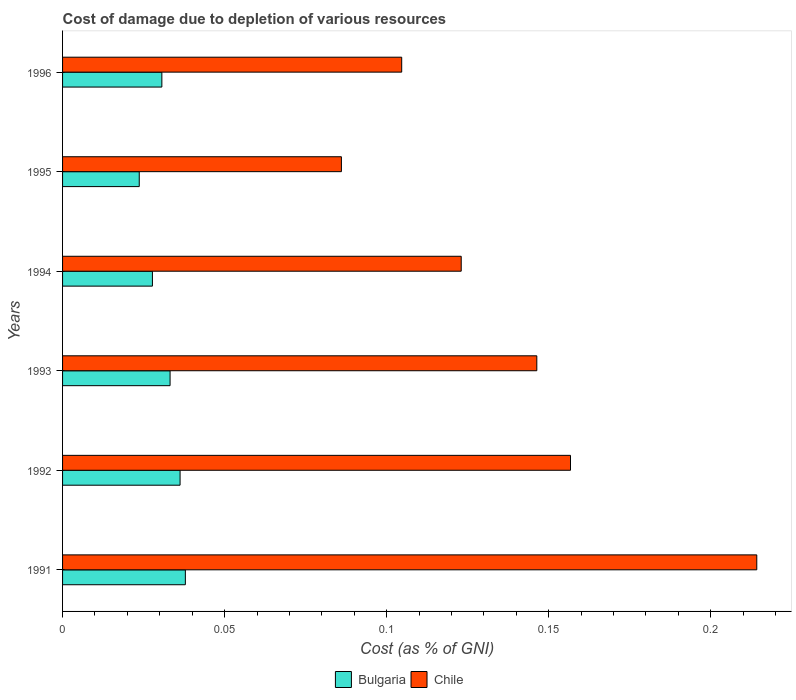Are the number of bars on each tick of the Y-axis equal?
Provide a succinct answer. Yes. How many bars are there on the 6th tick from the bottom?
Ensure brevity in your answer.  2. What is the label of the 4th group of bars from the top?
Provide a short and direct response. 1993. In how many cases, is the number of bars for a given year not equal to the number of legend labels?
Your answer should be very brief. 0. What is the cost of damage caused due to the depletion of various resources in Chile in 1996?
Provide a short and direct response. 0.1. Across all years, what is the maximum cost of damage caused due to the depletion of various resources in Chile?
Give a very brief answer. 0.21. Across all years, what is the minimum cost of damage caused due to the depletion of various resources in Chile?
Offer a terse response. 0.09. In which year was the cost of damage caused due to the depletion of various resources in Bulgaria maximum?
Offer a very short reply. 1991. In which year was the cost of damage caused due to the depletion of various resources in Chile minimum?
Your answer should be compact. 1995. What is the total cost of damage caused due to the depletion of various resources in Chile in the graph?
Your response must be concise. 0.83. What is the difference between the cost of damage caused due to the depletion of various resources in Bulgaria in 1991 and that in 1995?
Provide a short and direct response. 0.01. What is the difference between the cost of damage caused due to the depletion of various resources in Chile in 1994 and the cost of damage caused due to the depletion of various resources in Bulgaria in 1993?
Your response must be concise. 0.09. What is the average cost of damage caused due to the depletion of various resources in Bulgaria per year?
Offer a terse response. 0.03. In the year 1992, what is the difference between the cost of damage caused due to the depletion of various resources in Bulgaria and cost of damage caused due to the depletion of various resources in Chile?
Ensure brevity in your answer.  -0.12. In how many years, is the cost of damage caused due to the depletion of various resources in Chile greater than 0.01 %?
Make the answer very short. 6. What is the ratio of the cost of damage caused due to the depletion of various resources in Bulgaria in 1992 to that in 1993?
Make the answer very short. 1.09. Is the cost of damage caused due to the depletion of various resources in Chile in 1994 less than that in 1996?
Provide a succinct answer. No. Is the difference between the cost of damage caused due to the depletion of various resources in Bulgaria in 1991 and 1994 greater than the difference between the cost of damage caused due to the depletion of various resources in Chile in 1991 and 1994?
Keep it short and to the point. No. What is the difference between the highest and the second highest cost of damage caused due to the depletion of various resources in Bulgaria?
Give a very brief answer. 0. What is the difference between the highest and the lowest cost of damage caused due to the depletion of various resources in Chile?
Your answer should be compact. 0.13. Is the sum of the cost of damage caused due to the depletion of various resources in Chile in 1991 and 1995 greater than the maximum cost of damage caused due to the depletion of various resources in Bulgaria across all years?
Your answer should be very brief. Yes. What does the 2nd bar from the top in 1993 represents?
Ensure brevity in your answer.  Bulgaria. What does the 2nd bar from the bottom in 1993 represents?
Your response must be concise. Chile. How many years are there in the graph?
Offer a terse response. 6. What is the difference between two consecutive major ticks on the X-axis?
Provide a succinct answer. 0.05. Does the graph contain any zero values?
Make the answer very short. No. Does the graph contain grids?
Your answer should be very brief. No. Where does the legend appear in the graph?
Ensure brevity in your answer.  Bottom center. How are the legend labels stacked?
Keep it short and to the point. Horizontal. What is the title of the graph?
Keep it short and to the point. Cost of damage due to depletion of various resources. Does "Latvia" appear as one of the legend labels in the graph?
Make the answer very short. No. What is the label or title of the X-axis?
Give a very brief answer. Cost (as % of GNI). What is the Cost (as % of GNI) in Bulgaria in 1991?
Offer a terse response. 0.04. What is the Cost (as % of GNI) of Chile in 1991?
Your answer should be very brief. 0.21. What is the Cost (as % of GNI) in Bulgaria in 1992?
Provide a succinct answer. 0.04. What is the Cost (as % of GNI) of Chile in 1992?
Your answer should be very brief. 0.16. What is the Cost (as % of GNI) in Bulgaria in 1993?
Keep it short and to the point. 0.03. What is the Cost (as % of GNI) of Chile in 1993?
Make the answer very short. 0.15. What is the Cost (as % of GNI) of Bulgaria in 1994?
Offer a very short reply. 0.03. What is the Cost (as % of GNI) in Chile in 1994?
Your response must be concise. 0.12. What is the Cost (as % of GNI) of Bulgaria in 1995?
Keep it short and to the point. 0.02. What is the Cost (as % of GNI) of Chile in 1995?
Make the answer very short. 0.09. What is the Cost (as % of GNI) of Bulgaria in 1996?
Provide a short and direct response. 0.03. What is the Cost (as % of GNI) in Chile in 1996?
Your answer should be very brief. 0.1. Across all years, what is the maximum Cost (as % of GNI) in Bulgaria?
Make the answer very short. 0.04. Across all years, what is the maximum Cost (as % of GNI) in Chile?
Make the answer very short. 0.21. Across all years, what is the minimum Cost (as % of GNI) in Bulgaria?
Provide a short and direct response. 0.02. Across all years, what is the minimum Cost (as % of GNI) of Chile?
Your answer should be compact. 0.09. What is the total Cost (as % of GNI) of Bulgaria in the graph?
Provide a succinct answer. 0.19. What is the total Cost (as % of GNI) in Chile in the graph?
Offer a very short reply. 0.83. What is the difference between the Cost (as % of GNI) in Bulgaria in 1991 and that in 1992?
Give a very brief answer. 0. What is the difference between the Cost (as % of GNI) of Chile in 1991 and that in 1992?
Provide a short and direct response. 0.06. What is the difference between the Cost (as % of GNI) of Bulgaria in 1991 and that in 1993?
Provide a short and direct response. 0. What is the difference between the Cost (as % of GNI) of Chile in 1991 and that in 1993?
Ensure brevity in your answer.  0.07. What is the difference between the Cost (as % of GNI) in Bulgaria in 1991 and that in 1994?
Offer a very short reply. 0.01. What is the difference between the Cost (as % of GNI) in Chile in 1991 and that in 1994?
Ensure brevity in your answer.  0.09. What is the difference between the Cost (as % of GNI) of Bulgaria in 1991 and that in 1995?
Offer a terse response. 0.01. What is the difference between the Cost (as % of GNI) of Chile in 1991 and that in 1995?
Ensure brevity in your answer.  0.13. What is the difference between the Cost (as % of GNI) in Bulgaria in 1991 and that in 1996?
Your answer should be compact. 0.01. What is the difference between the Cost (as % of GNI) in Chile in 1991 and that in 1996?
Your response must be concise. 0.11. What is the difference between the Cost (as % of GNI) of Bulgaria in 1992 and that in 1993?
Make the answer very short. 0. What is the difference between the Cost (as % of GNI) in Chile in 1992 and that in 1993?
Give a very brief answer. 0.01. What is the difference between the Cost (as % of GNI) in Bulgaria in 1992 and that in 1994?
Give a very brief answer. 0.01. What is the difference between the Cost (as % of GNI) in Chile in 1992 and that in 1994?
Offer a very short reply. 0.03. What is the difference between the Cost (as % of GNI) in Bulgaria in 1992 and that in 1995?
Provide a short and direct response. 0.01. What is the difference between the Cost (as % of GNI) of Chile in 1992 and that in 1995?
Ensure brevity in your answer.  0.07. What is the difference between the Cost (as % of GNI) of Bulgaria in 1992 and that in 1996?
Offer a terse response. 0.01. What is the difference between the Cost (as % of GNI) of Chile in 1992 and that in 1996?
Provide a succinct answer. 0.05. What is the difference between the Cost (as % of GNI) of Bulgaria in 1993 and that in 1994?
Keep it short and to the point. 0.01. What is the difference between the Cost (as % of GNI) in Chile in 1993 and that in 1994?
Ensure brevity in your answer.  0.02. What is the difference between the Cost (as % of GNI) in Bulgaria in 1993 and that in 1995?
Your answer should be very brief. 0.01. What is the difference between the Cost (as % of GNI) of Chile in 1993 and that in 1995?
Keep it short and to the point. 0.06. What is the difference between the Cost (as % of GNI) of Bulgaria in 1993 and that in 1996?
Your answer should be very brief. 0. What is the difference between the Cost (as % of GNI) of Chile in 1993 and that in 1996?
Give a very brief answer. 0.04. What is the difference between the Cost (as % of GNI) in Bulgaria in 1994 and that in 1995?
Keep it short and to the point. 0. What is the difference between the Cost (as % of GNI) in Chile in 1994 and that in 1995?
Provide a short and direct response. 0.04. What is the difference between the Cost (as % of GNI) of Bulgaria in 1994 and that in 1996?
Give a very brief answer. -0. What is the difference between the Cost (as % of GNI) in Chile in 1994 and that in 1996?
Give a very brief answer. 0.02. What is the difference between the Cost (as % of GNI) of Bulgaria in 1995 and that in 1996?
Ensure brevity in your answer.  -0.01. What is the difference between the Cost (as % of GNI) in Chile in 1995 and that in 1996?
Make the answer very short. -0.02. What is the difference between the Cost (as % of GNI) of Bulgaria in 1991 and the Cost (as % of GNI) of Chile in 1992?
Your answer should be very brief. -0.12. What is the difference between the Cost (as % of GNI) in Bulgaria in 1991 and the Cost (as % of GNI) in Chile in 1993?
Your response must be concise. -0.11. What is the difference between the Cost (as % of GNI) in Bulgaria in 1991 and the Cost (as % of GNI) in Chile in 1994?
Your answer should be very brief. -0.09. What is the difference between the Cost (as % of GNI) of Bulgaria in 1991 and the Cost (as % of GNI) of Chile in 1995?
Your answer should be very brief. -0.05. What is the difference between the Cost (as % of GNI) of Bulgaria in 1991 and the Cost (as % of GNI) of Chile in 1996?
Provide a succinct answer. -0.07. What is the difference between the Cost (as % of GNI) in Bulgaria in 1992 and the Cost (as % of GNI) in Chile in 1993?
Keep it short and to the point. -0.11. What is the difference between the Cost (as % of GNI) in Bulgaria in 1992 and the Cost (as % of GNI) in Chile in 1994?
Give a very brief answer. -0.09. What is the difference between the Cost (as % of GNI) of Bulgaria in 1992 and the Cost (as % of GNI) of Chile in 1995?
Offer a terse response. -0.05. What is the difference between the Cost (as % of GNI) in Bulgaria in 1992 and the Cost (as % of GNI) in Chile in 1996?
Make the answer very short. -0.07. What is the difference between the Cost (as % of GNI) in Bulgaria in 1993 and the Cost (as % of GNI) in Chile in 1994?
Your answer should be very brief. -0.09. What is the difference between the Cost (as % of GNI) in Bulgaria in 1993 and the Cost (as % of GNI) in Chile in 1995?
Provide a succinct answer. -0.05. What is the difference between the Cost (as % of GNI) in Bulgaria in 1993 and the Cost (as % of GNI) in Chile in 1996?
Give a very brief answer. -0.07. What is the difference between the Cost (as % of GNI) of Bulgaria in 1994 and the Cost (as % of GNI) of Chile in 1995?
Your answer should be very brief. -0.06. What is the difference between the Cost (as % of GNI) in Bulgaria in 1994 and the Cost (as % of GNI) in Chile in 1996?
Make the answer very short. -0.08. What is the difference between the Cost (as % of GNI) in Bulgaria in 1995 and the Cost (as % of GNI) in Chile in 1996?
Ensure brevity in your answer.  -0.08. What is the average Cost (as % of GNI) of Bulgaria per year?
Ensure brevity in your answer.  0.03. What is the average Cost (as % of GNI) of Chile per year?
Ensure brevity in your answer.  0.14. In the year 1991, what is the difference between the Cost (as % of GNI) in Bulgaria and Cost (as % of GNI) in Chile?
Make the answer very short. -0.18. In the year 1992, what is the difference between the Cost (as % of GNI) of Bulgaria and Cost (as % of GNI) of Chile?
Give a very brief answer. -0.12. In the year 1993, what is the difference between the Cost (as % of GNI) in Bulgaria and Cost (as % of GNI) in Chile?
Make the answer very short. -0.11. In the year 1994, what is the difference between the Cost (as % of GNI) in Bulgaria and Cost (as % of GNI) in Chile?
Keep it short and to the point. -0.1. In the year 1995, what is the difference between the Cost (as % of GNI) in Bulgaria and Cost (as % of GNI) in Chile?
Ensure brevity in your answer.  -0.06. In the year 1996, what is the difference between the Cost (as % of GNI) of Bulgaria and Cost (as % of GNI) of Chile?
Offer a very short reply. -0.07. What is the ratio of the Cost (as % of GNI) in Bulgaria in 1991 to that in 1992?
Give a very brief answer. 1.04. What is the ratio of the Cost (as % of GNI) of Chile in 1991 to that in 1992?
Provide a succinct answer. 1.37. What is the ratio of the Cost (as % of GNI) in Bulgaria in 1991 to that in 1993?
Provide a succinct answer. 1.14. What is the ratio of the Cost (as % of GNI) of Chile in 1991 to that in 1993?
Provide a short and direct response. 1.46. What is the ratio of the Cost (as % of GNI) in Bulgaria in 1991 to that in 1994?
Keep it short and to the point. 1.37. What is the ratio of the Cost (as % of GNI) in Chile in 1991 to that in 1994?
Make the answer very short. 1.74. What is the ratio of the Cost (as % of GNI) in Bulgaria in 1991 to that in 1995?
Give a very brief answer. 1.6. What is the ratio of the Cost (as % of GNI) of Chile in 1991 to that in 1995?
Provide a succinct answer. 2.49. What is the ratio of the Cost (as % of GNI) in Bulgaria in 1991 to that in 1996?
Provide a short and direct response. 1.24. What is the ratio of the Cost (as % of GNI) in Chile in 1991 to that in 1996?
Provide a succinct answer. 2.05. What is the ratio of the Cost (as % of GNI) of Bulgaria in 1992 to that in 1993?
Provide a succinct answer. 1.09. What is the ratio of the Cost (as % of GNI) in Chile in 1992 to that in 1993?
Ensure brevity in your answer.  1.07. What is the ratio of the Cost (as % of GNI) in Bulgaria in 1992 to that in 1994?
Provide a succinct answer. 1.31. What is the ratio of the Cost (as % of GNI) of Chile in 1992 to that in 1994?
Make the answer very short. 1.27. What is the ratio of the Cost (as % of GNI) in Bulgaria in 1992 to that in 1995?
Offer a terse response. 1.53. What is the ratio of the Cost (as % of GNI) in Chile in 1992 to that in 1995?
Keep it short and to the point. 1.82. What is the ratio of the Cost (as % of GNI) of Bulgaria in 1992 to that in 1996?
Keep it short and to the point. 1.18. What is the ratio of the Cost (as % of GNI) of Chile in 1992 to that in 1996?
Your response must be concise. 1.5. What is the ratio of the Cost (as % of GNI) of Bulgaria in 1993 to that in 1994?
Ensure brevity in your answer.  1.2. What is the ratio of the Cost (as % of GNI) in Chile in 1993 to that in 1994?
Give a very brief answer. 1.19. What is the ratio of the Cost (as % of GNI) in Bulgaria in 1993 to that in 1995?
Provide a short and direct response. 1.4. What is the ratio of the Cost (as % of GNI) of Chile in 1993 to that in 1995?
Offer a very short reply. 1.7. What is the ratio of the Cost (as % of GNI) of Bulgaria in 1993 to that in 1996?
Ensure brevity in your answer.  1.08. What is the ratio of the Cost (as % of GNI) of Chile in 1993 to that in 1996?
Give a very brief answer. 1.4. What is the ratio of the Cost (as % of GNI) in Bulgaria in 1994 to that in 1995?
Provide a succinct answer. 1.17. What is the ratio of the Cost (as % of GNI) of Chile in 1994 to that in 1995?
Provide a short and direct response. 1.43. What is the ratio of the Cost (as % of GNI) in Bulgaria in 1994 to that in 1996?
Your answer should be very brief. 0.9. What is the ratio of the Cost (as % of GNI) of Chile in 1994 to that in 1996?
Your answer should be very brief. 1.18. What is the ratio of the Cost (as % of GNI) of Bulgaria in 1995 to that in 1996?
Your response must be concise. 0.77. What is the ratio of the Cost (as % of GNI) in Chile in 1995 to that in 1996?
Your answer should be very brief. 0.82. What is the difference between the highest and the second highest Cost (as % of GNI) in Bulgaria?
Make the answer very short. 0. What is the difference between the highest and the second highest Cost (as % of GNI) in Chile?
Ensure brevity in your answer.  0.06. What is the difference between the highest and the lowest Cost (as % of GNI) of Bulgaria?
Your response must be concise. 0.01. What is the difference between the highest and the lowest Cost (as % of GNI) in Chile?
Provide a succinct answer. 0.13. 